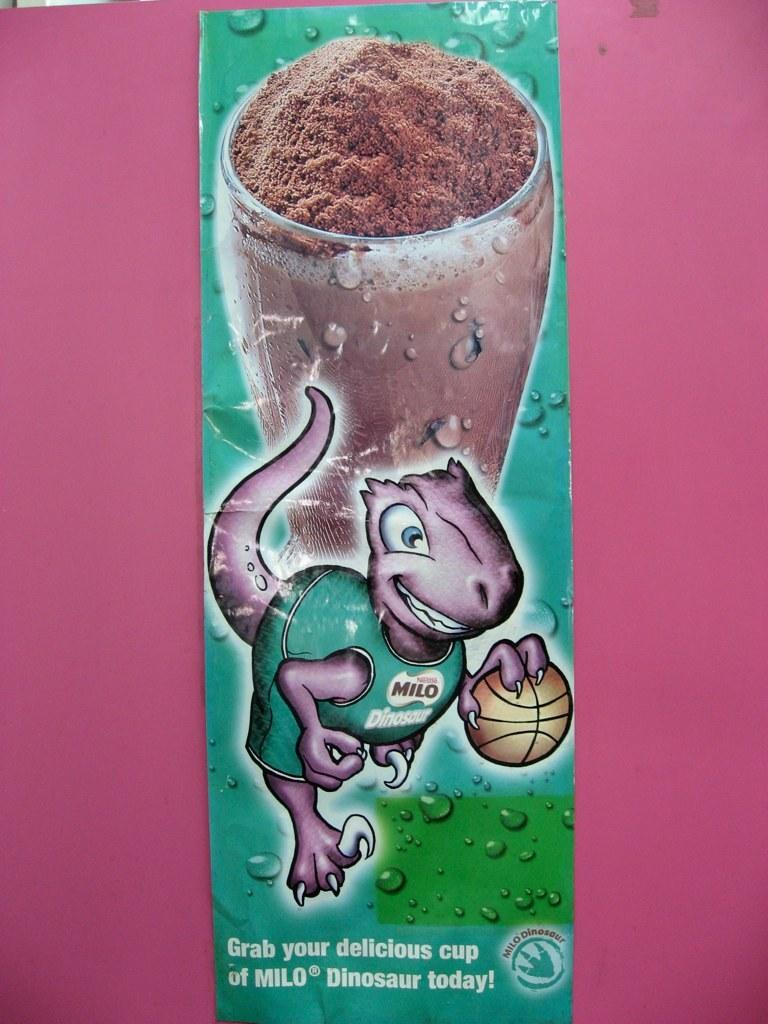What is the main object in the image? There is a banner in the image. What is depicted on the banner? The banner has a cartoon image on it, as well as a glass. What type of text is written on the banner? There is text written on the banner. What color is the surface the banner is on? The banner is on a pink surface. What type of trucks are shown in the cartoon image on the banner? There are no trucks depicted in the cartoon image on the banner; it only features a glass. What riddle is written on the banner? There is no riddle written on the banner; it contains text, but not a riddle. 